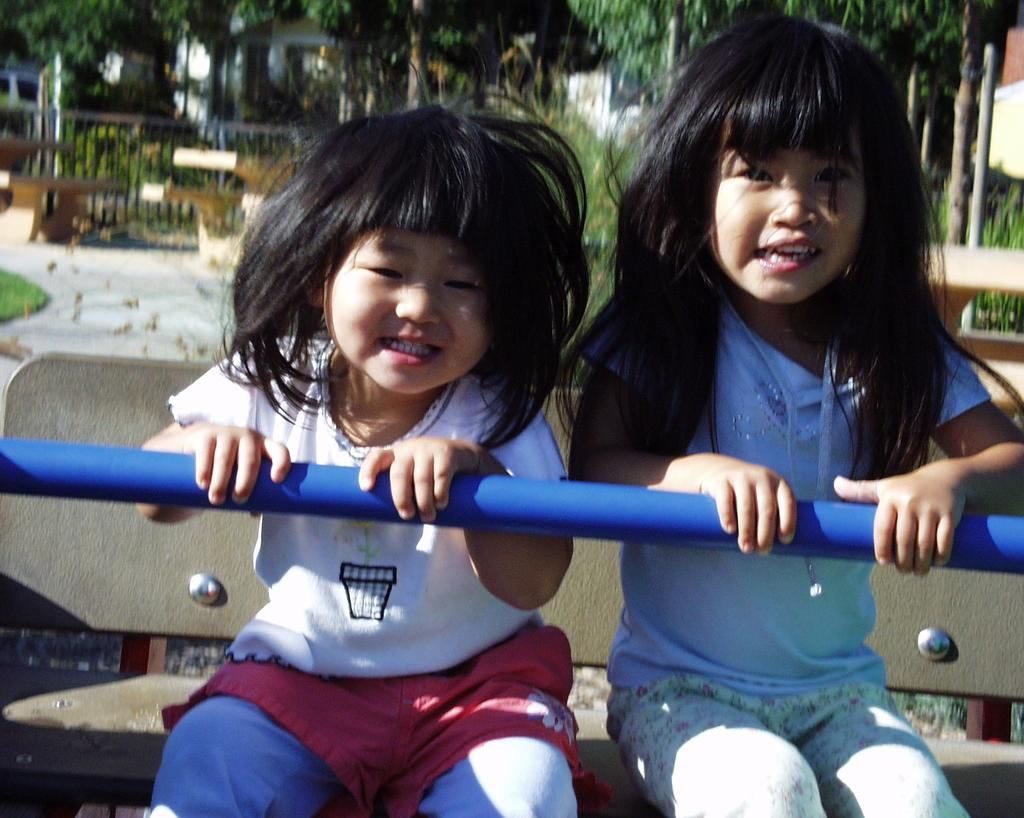How many girls are in the image? There are two girls in the image. What are the girls doing in the image? The girls are sitting on a bench and holding a rod. What can be seen in the background of the image? There is a fence, trees, and a shed in the background of the image. What type of pail can be seen on the top of the shed in the image? There is no pail visible on the top of the shed in the image. 